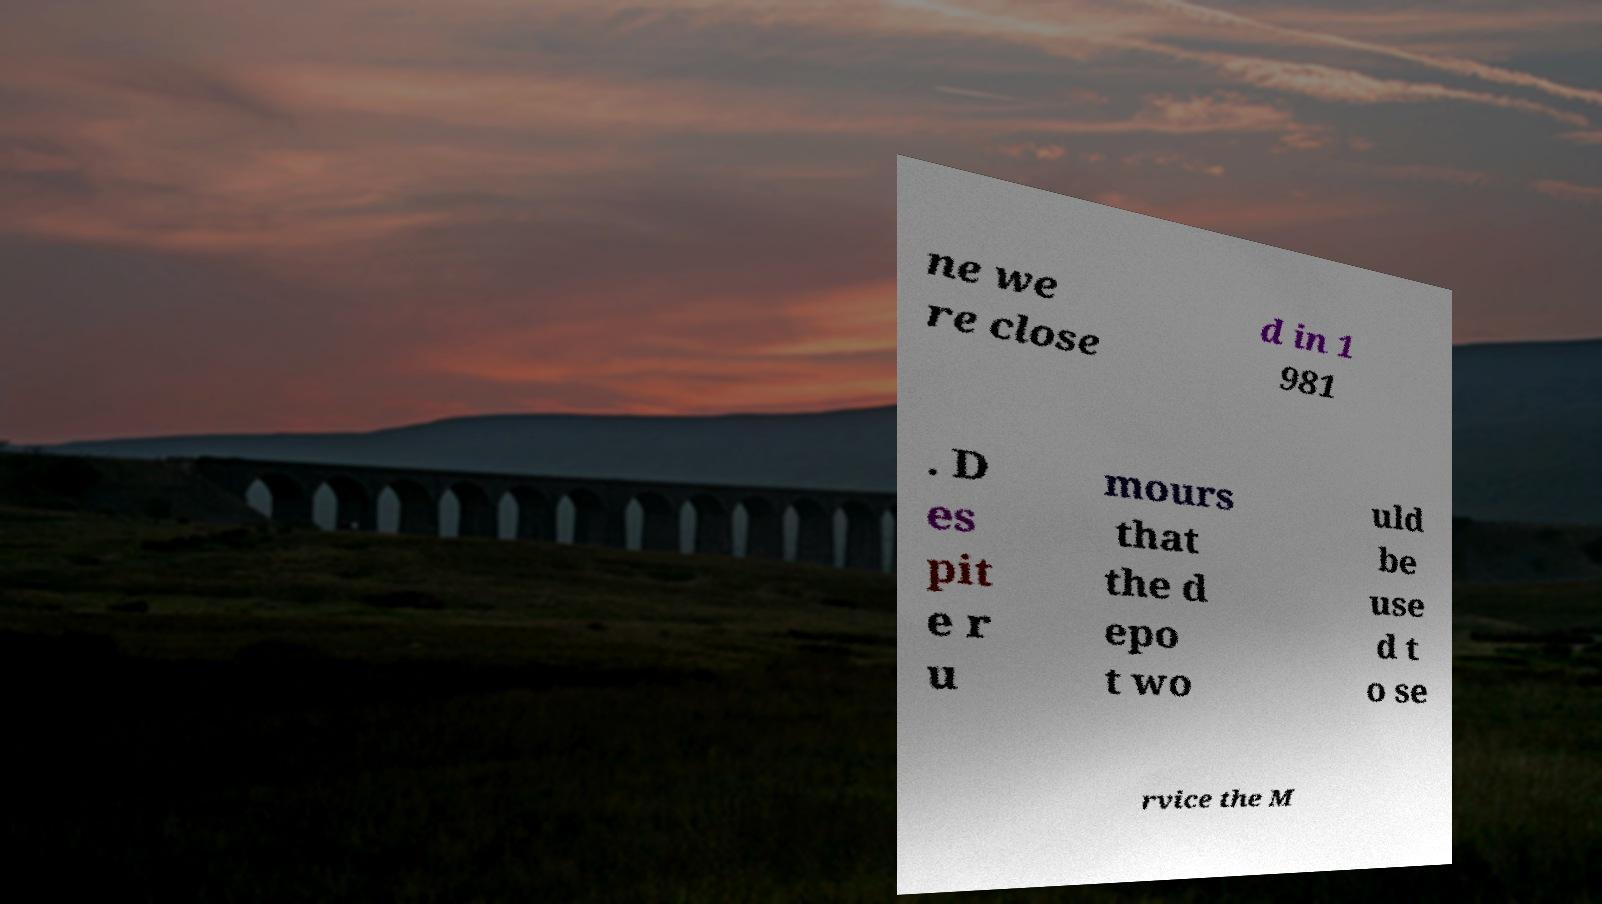Could you extract and type out the text from this image? ne we re close d in 1 981 . D es pit e r u mours that the d epo t wo uld be use d t o se rvice the M 